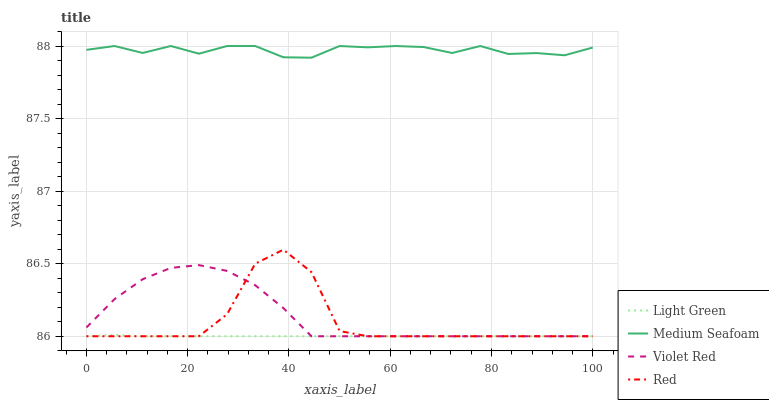Does Light Green have the minimum area under the curve?
Answer yes or no. Yes. Does Medium Seafoam have the maximum area under the curve?
Answer yes or no. Yes. Does Violet Red have the minimum area under the curve?
Answer yes or no. No. Does Violet Red have the maximum area under the curve?
Answer yes or no. No. Is Light Green the smoothest?
Answer yes or no. Yes. Is Red the roughest?
Answer yes or no. Yes. Is Violet Red the smoothest?
Answer yes or no. No. Is Violet Red the roughest?
Answer yes or no. No. Does Medium Seafoam have the lowest value?
Answer yes or no. No. Does Medium Seafoam have the highest value?
Answer yes or no. Yes. Does Violet Red have the highest value?
Answer yes or no. No. Is Violet Red less than Medium Seafoam?
Answer yes or no. Yes. Is Medium Seafoam greater than Violet Red?
Answer yes or no. Yes. Does Light Green intersect Violet Red?
Answer yes or no. Yes. Is Light Green less than Violet Red?
Answer yes or no. No. Is Light Green greater than Violet Red?
Answer yes or no. No. Does Violet Red intersect Medium Seafoam?
Answer yes or no. No. 